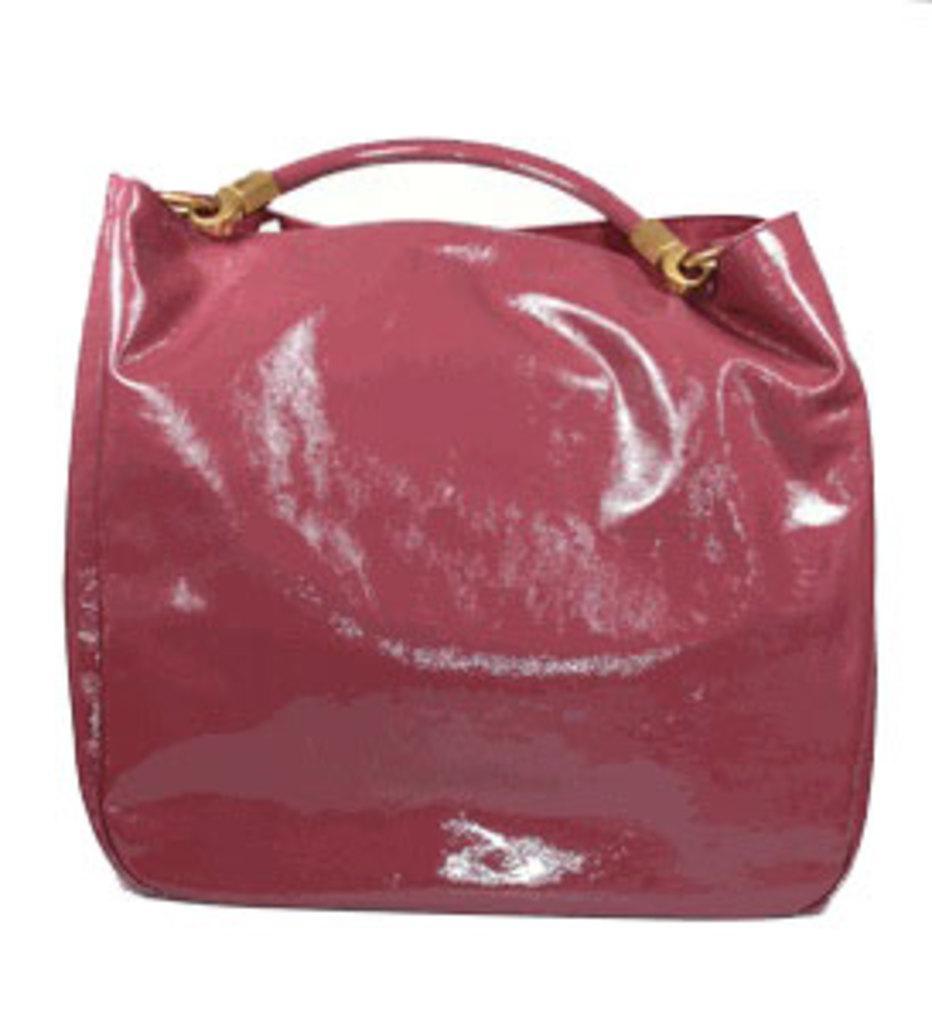Describe this image in one or two sentences. In this picture we can see a red color bag with steel item handed to it. 